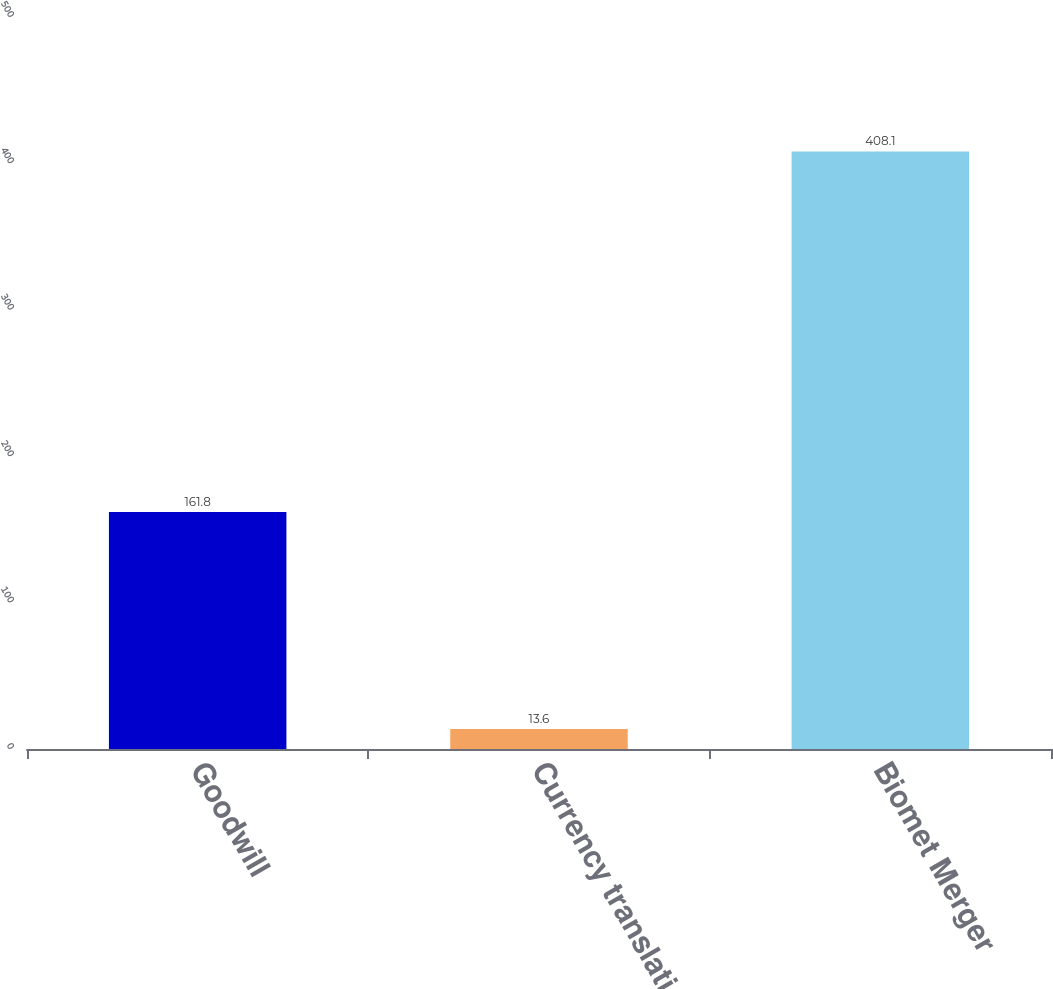Convert chart to OTSL. <chart><loc_0><loc_0><loc_500><loc_500><bar_chart><fcel>Goodwill<fcel>Currency translation<fcel>Biomet Merger<nl><fcel>161.8<fcel>13.6<fcel>408.1<nl></chart> 